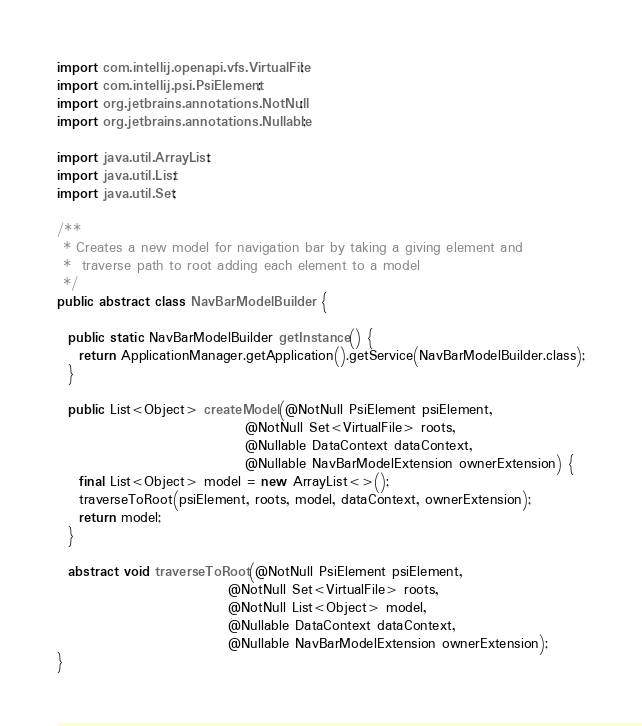Convert code to text. <code><loc_0><loc_0><loc_500><loc_500><_Java_>import com.intellij.openapi.vfs.VirtualFile;
import com.intellij.psi.PsiElement;
import org.jetbrains.annotations.NotNull;
import org.jetbrains.annotations.Nullable;

import java.util.ArrayList;
import java.util.List;
import java.util.Set;

/**
 * Creates a new model for navigation bar by taking a giving element and
 *  traverse path to root adding each element to a model
 */
public abstract class NavBarModelBuilder {

  public static NavBarModelBuilder getInstance() {
    return ApplicationManager.getApplication().getService(NavBarModelBuilder.class);
  }

  public List<Object> createModel(@NotNull PsiElement psiElement,
                                  @NotNull Set<VirtualFile> roots,
                                  @Nullable DataContext dataContext,
                                  @Nullable NavBarModelExtension ownerExtension) {
    final List<Object> model = new ArrayList<>();
    traverseToRoot(psiElement, roots, model, dataContext, ownerExtension);
    return model;
  }

  abstract void traverseToRoot(@NotNull PsiElement psiElement,
                               @NotNull Set<VirtualFile> roots,
                               @NotNull List<Object> model,
                               @Nullable DataContext dataContext,
                               @Nullable NavBarModelExtension ownerExtension);
}

</code> 